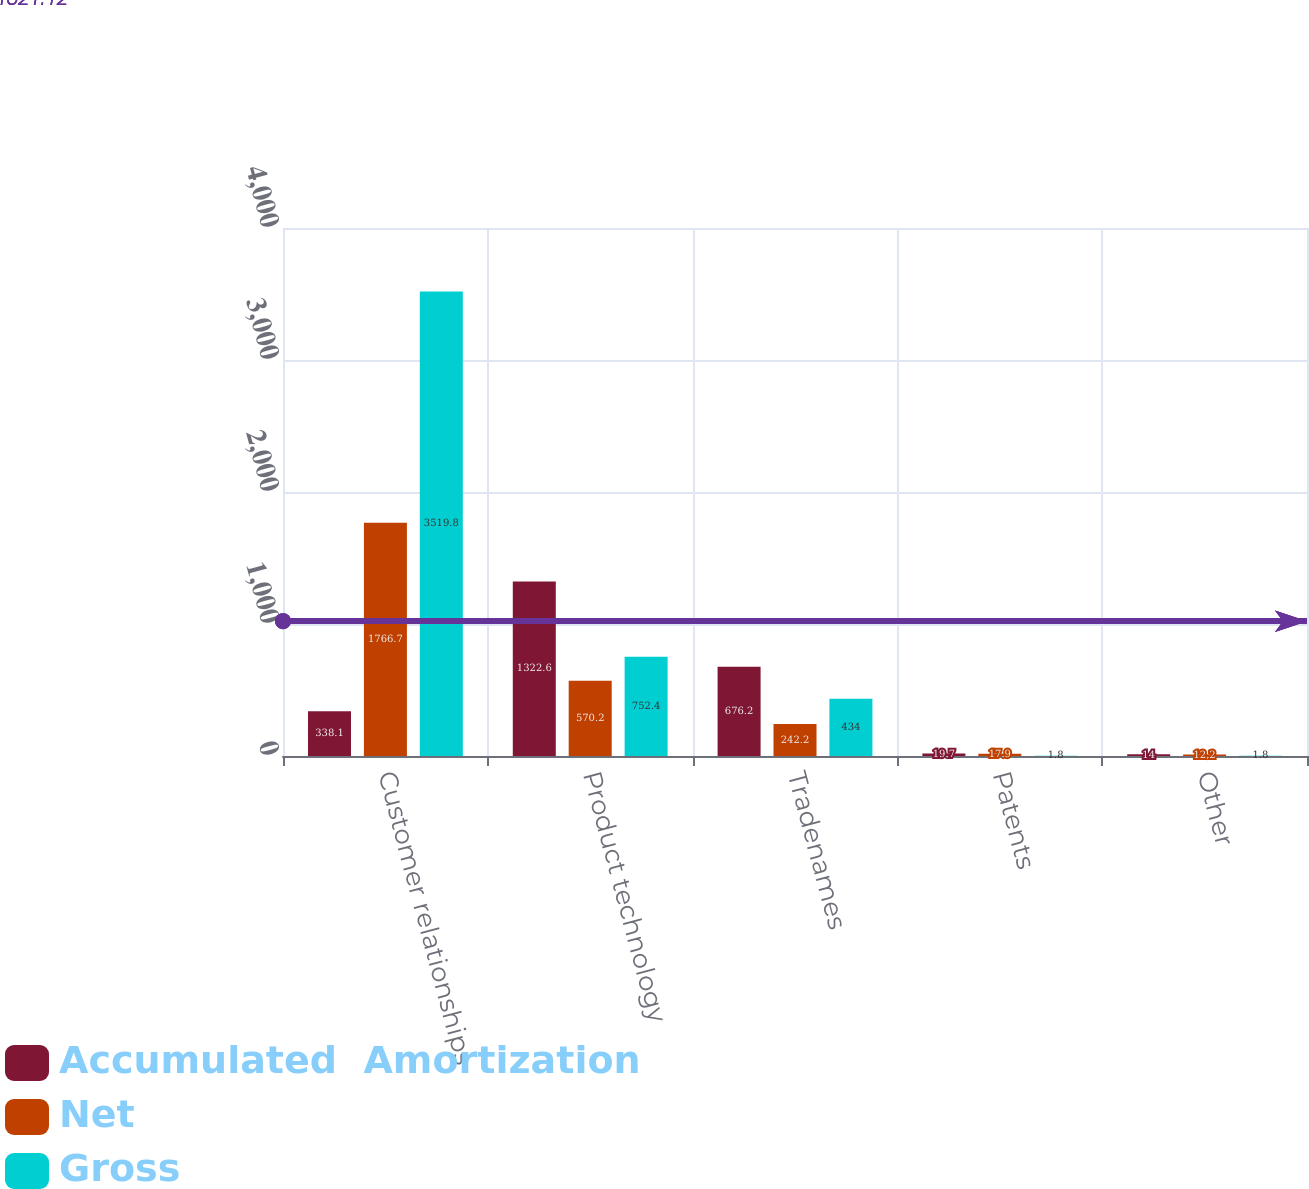<chart> <loc_0><loc_0><loc_500><loc_500><stacked_bar_chart><ecel><fcel>Customer relationships<fcel>Product technology<fcel>Tradenames<fcel>Patents<fcel>Other<nl><fcel>Accumulated  Amortization<fcel>338.1<fcel>1322.6<fcel>676.2<fcel>19.7<fcel>14<nl><fcel>Net<fcel>1766.7<fcel>570.2<fcel>242.2<fcel>17.9<fcel>12.2<nl><fcel>Gross<fcel>3519.8<fcel>752.4<fcel>434<fcel>1.8<fcel>1.8<nl></chart> 